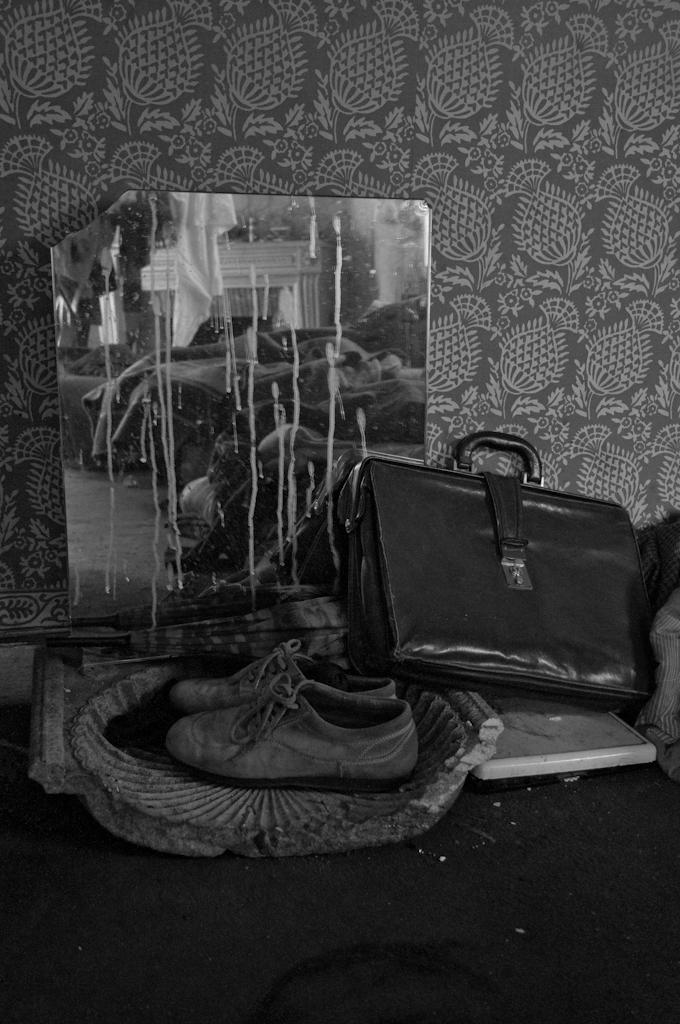What type of footwear is visible in the image? There is a pair of shoes in the image. What other item can be seen in the image besides the shoes? There is a bag in the image. What is placed on the floor in the image? There is a poster on the floor in the image. How many fairies are dancing around the shoes in the image? There are no fairies present in the image; it only features a pair of shoes, a bag, and a poster on the floor. 